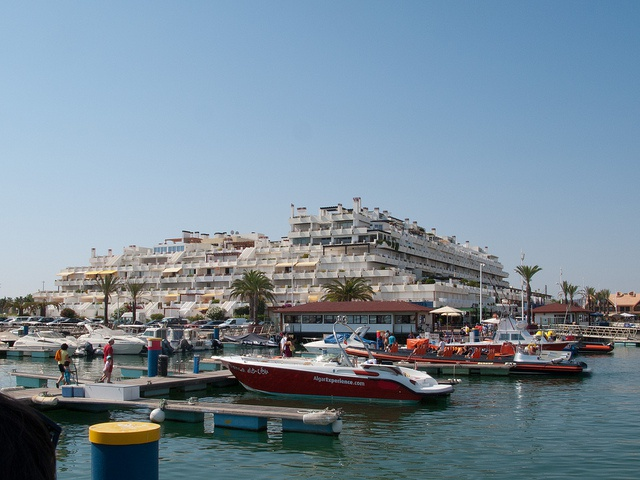Describe the objects in this image and their specific colors. I can see boat in lightblue, black, lightgray, gray, and darkgray tones, boat in lightblue, black, maroon, gray, and brown tones, boat in lightblue, darkgray, gray, lightgray, and black tones, boat in lightblue, darkgray, black, gray, and maroon tones, and boat in lightblue, gray, darkgray, black, and lightgray tones in this image. 